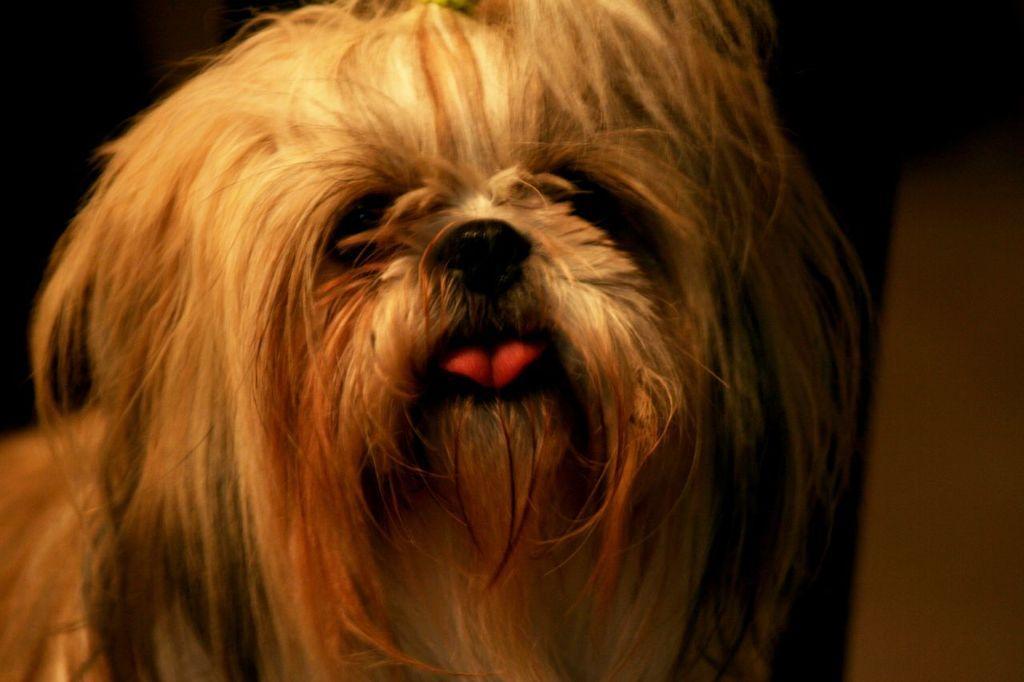Please provide a concise description of this image. In this picture I can see a dog which is of white and cream in color. I see that it dark in the background. 